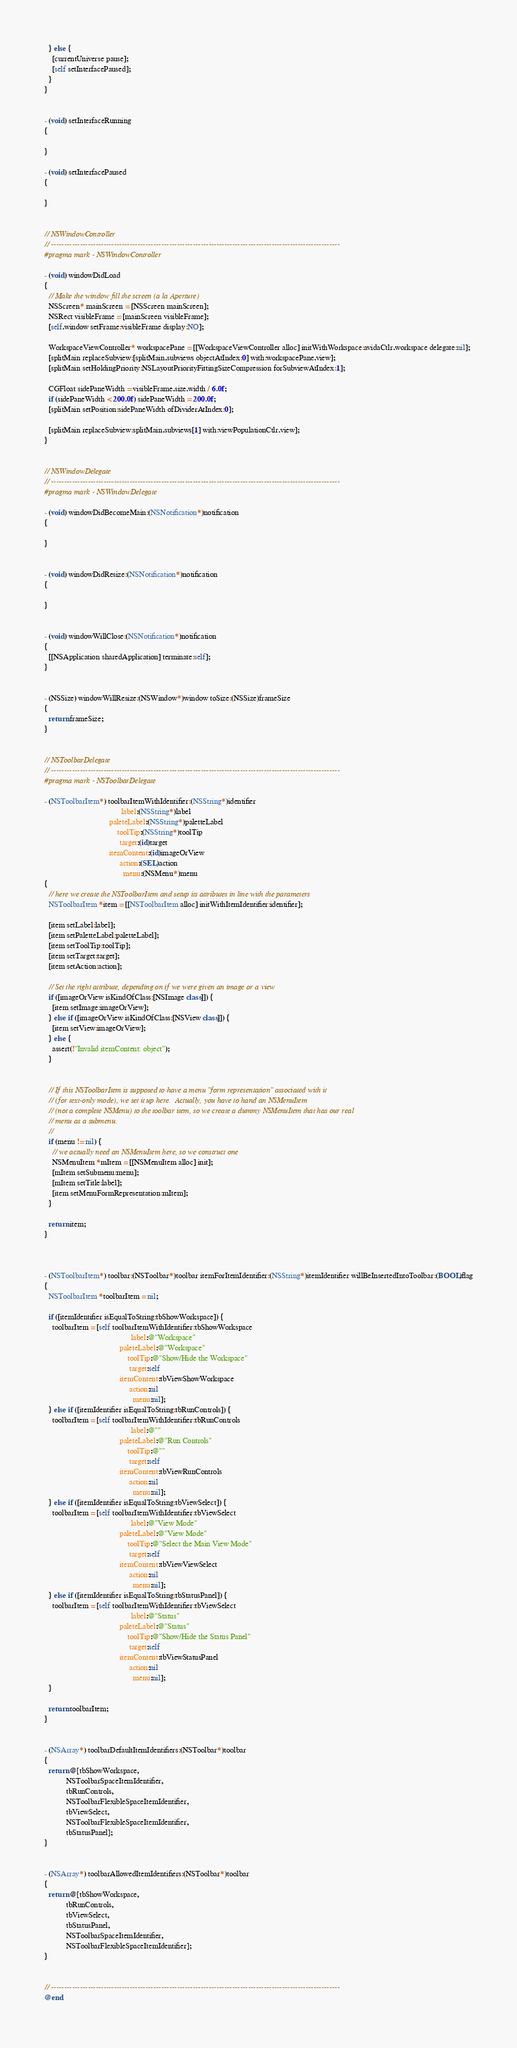Convert code to text. <code><loc_0><loc_0><loc_500><loc_500><_ObjectiveC_>  } else {
    [currentUniverse pause];
    [self setInterfacePaused];
  }
}


- (void) setInterfaceRunning
{
  
}

- (void) setInterfacePaused
{
  
}


// NSWindowController
// --------------------------------------------------------------------------------------------------------------
#pragma mark - NSWindowController

- (void) windowDidLoad
{
  // Make the window fill the screen (a la Aperture)
  NSScreen* mainScreen = [NSScreen mainScreen];
  NSRect visibleFrame = [mainScreen visibleFrame];
  [self.window setFrame:visibleFrame display:NO];

  WorkspaceViewController* workspacePane = [[WorkspaceViewController alloc] initWithWorkspace:avidaCtlr.workspace delegate:nil];
  [splitMain replaceSubview:[splitMain.subviews objectAtIndex:0] with:workspacePane.view];
  [splitMain setHoldingPriority:NSLayoutPriorityFittingSizeCompression forSubviewAtIndex:1];
  
  CGFloat sidePaneWidth = visibleFrame.size.width / 6.0f;
  if (sidePaneWidth < 200.0f) sidePaneWidth = 200.0f;
  [splitMain setPosition:sidePaneWidth ofDividerAtIndex:0];
  
  [splitMain replaceSubview:splitMain.subviews[1] with:viewPopulationCtlr.view];
}


// NSWindowDelegate
// --------------------------------------------------------------------------------------------------------------
#pragma mark - NSWindowDelegate

- (void) windowDidBecomeMain:(NSNotification*)notification
{
  
}


- (void) windowDidResize:(NSNotification*)notification
{
  
}


- (void) windowWillClose:(NSNotification*)notification
{
  [[NSApplication sharedApplication] terminate:self];
}


- (NSSize) windowWillResize:(NSWindow*)window toSize:(NSSize)frameSize
{
  return frameSize;
}


// NSToolbarDelegate
// --------------------------------------------------------------------------------------------------------------
#pragma mark - NSToolbarDelegate

- (NSToolbarItem*) toolbarItemWithIdentifier:(NSString*)identifier
                                       label:(NSString*)label
                                 paleteLabel:(NSString*)paletteLabel
                                     toolTip:(NSString*)toolTip
                                      target:(id)target
                                 itemContent:(id)imageOrView
                                      action:(SEL)action
                                        menu:(NSMenu*)menu
{
  // here we create the NSToolbarItem and setup its attributes in line with the parameters
  NSToolbarItem *item = [[NSToolbarItem alloc] initWithItemIdentifier:identifier];
  
  [item setLabel:label];
  [item setPaletteLabel:paletteLabel];
  [item setToolTip:toolTip];
  [item setTarget:target];
  [item setAction:action];
  
  // Set the right attribute, depending on if we were given an image or a view
  if ([imageOrView isKindOfClass:[NSImage class]]) {
    [item setImage:imageOrView];
  } else if ([imageOrView isKindOfClass:[NSView class]]) {
    [item setView:imageOrView];
  } else {
    assert(!"Invalid itemContent: object");
  }
  
  
  // If this NSToolbarItem is supposed to have a menu "form representation" associated with it
  // (for text-only mode), we set it up here.  Actually, you have to hand an NSMenuItem
  // (not a complete NSMenu) to the toolbar item, so we create a dummy NSMenuItem that has our real
  // menu as a submenu.
  //
  if (menu != nil) {
    // we actually need an NSMenuItem here, so we construct one
    NSMenuItem *mItem = [[NSMenuItem alloc] init];
    [mItem setSubmenu:menu];
    [mItem setTitle:label];
    [item setMenuFormRepresentation:mItem];
  }
  
  return item;
}



- (NSToolbarItem*) toolbar:(NSToolbar*)toolbar itemForItemIdentifier:(NSString*)itemIdentifier willBeInsertedIntoToolbar:(BOOL)flag
{
  NSToolbarItem *toolbarItem = nil;
  
  if ([itemIdentifier isEqualToString:tbShowWorkspace]) {
    toolbarItem = [self toolbarItemWithIdentifier:tbShowWorkspace
                                            label:@"Workspace"
                                      paleteLabel:@"Workspace"
                                          toolTip:@"Show/Hide the Workspace"
                                           target:self
                                      itemContent:tbViewShowWorkspace
                                           action:nil
                                             menu:nil];
  } else if ([itemIdentifier isEqualToString:tbRunControls]) {
    toolbarItem = [self toolbarItemWithIdentifier:tbRunControls
                                            label:@""
                                      paleteLabel:@"Run Controls"
                                          toolTip:@""
                                           target:self
                                      itemContent:tbViewRunControls
                                           action:nil
                                             menu:nil];
  } else if ([itemIdentifier isEqualToString:tbViewSelect]) {
    toolbarItem = [self toolbarItemWithIdentifier:tbViewSelect
                                            label:@"View Mode"
                                      paleteLabel:@"View Mode"
                                          toolTip:@"Select the Main View Mode"
                                           target:self
                                      itemContent:tbViewViewSelect
                                           action:nil
                                             menu:nil];
  } else if ([itemIdentifier isEqualToString:tbStatusPanel]) {
    toolbarItem = [self toolbarItemWithIdentifier:tbViewSelect
                                            label:@"Status"
                                      paleteLabel:@"Status"
                                          toolTip:@"Show/Hide the Status Panel"
                                           target:self
                                      itemContent:tbViewStatusPanel
                                           action:nil
                                             menu:nil];
  }
  
  return toolbarItem;
}


- (NSArray*) toolbarDefaultItemIdentifiers:(NSToolbar*)toolbar
{
  return @[tbShowWorkspace,
           NSToolbarSpaceItemIdentifier,
           tbRunControls,
           NSToolbarFlexibleSpaceItemIdentifier,
           tbViewSelect,
           NSToolbarFlexibleSpaceItemIdentifier,
           tbStatusPanel];
}


- (NSArray*) toolbarAllowedItemIdentifiers:(NSToolbar*)toolbar
{
  return @[tbShowWorkspace,
           tbRunControls,
           tbViewSelect,
           tbStatusPanel,
           NSToolbarSpaceItemIdentifier,
           NSToolbarFlexibleSpaceItemIdentifier];
}


// --------------------------------------------------------------------------------------------------------------
@end
</code> 